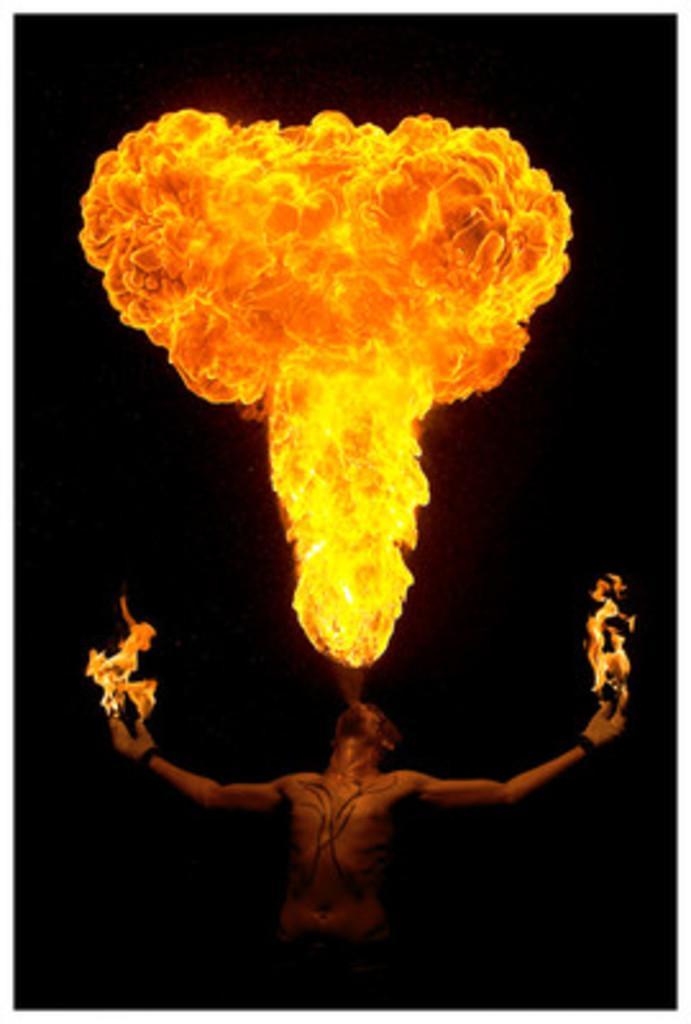Can you describe this image briefly? In this picture we can see a person standing, fire and in the background it is dark. 